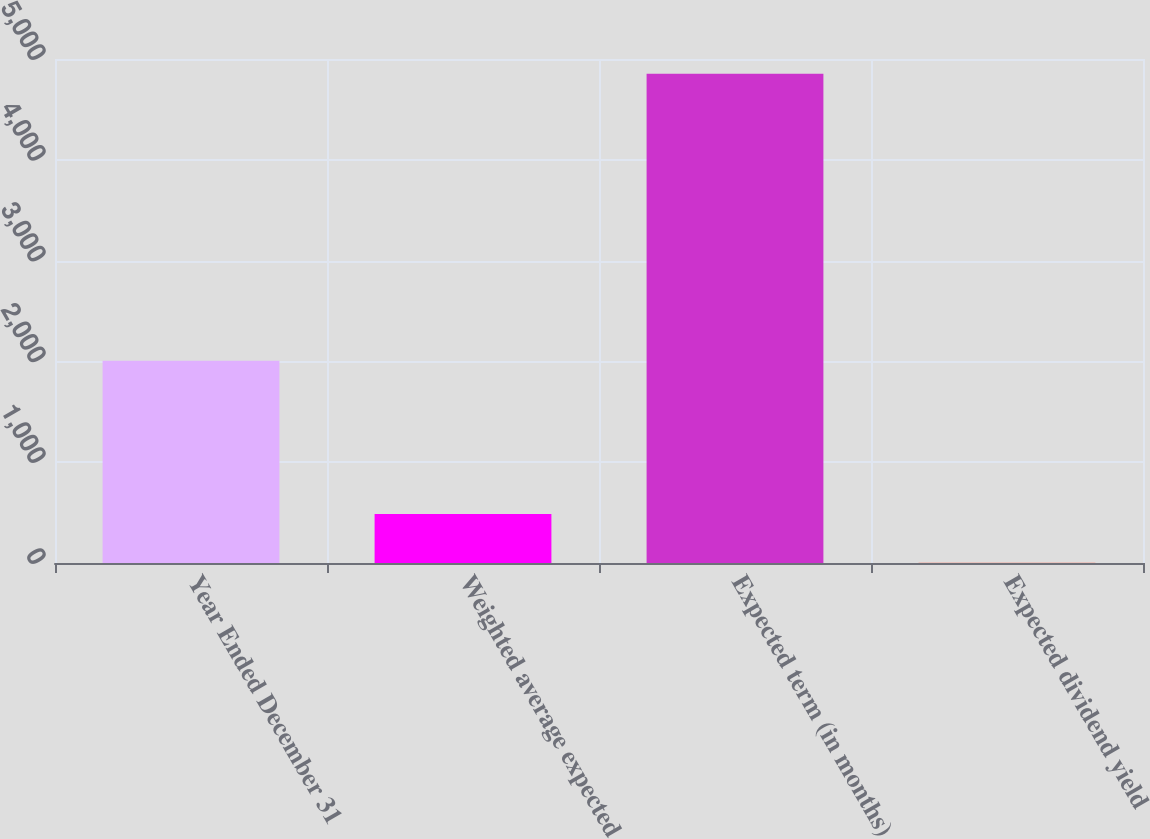Convert chart. <chart><loc_0><loc_0><loc_500><loc_500><bar_chart><fcel>Year Ended December 31<fcel>Weighted average expected<fcel>Expected term (in months)<fcel>Expected dividend yield<nl><fcel>2007<fcel>486.75<fcel>4854<fcel>1.5<nl></chart> 